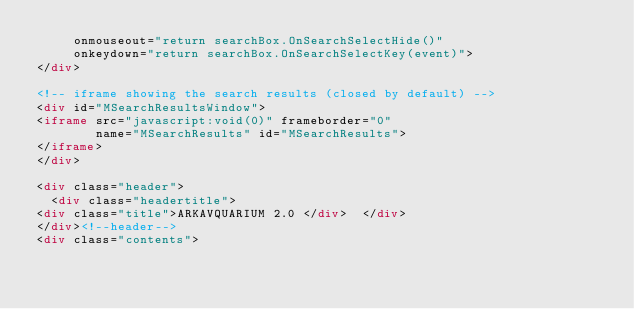Convert code to text. <code><loc_0><loc_0><loc_500><loc_500><_HTML_>     onmouseout="return searchBox.OnSearchSelectHide()"
     onkeydown="return searchBox.OnSearchSelectKey(event)">
</div>

<!-- iframe showing the search results (closed by default) -->
<div id="MSearchResultsWindow">
<iframe src="javascript:void(0)" frameborder="0" 
        name="MSearchResults" id="MSearchResults">
</iframe>
</div>

<div class="header">
  <div class="headertitle">
<div class="title">ARKAVQUARIUM 2.0 </div>  </div>
</div><!--header-->
<div class="contents"></code> 